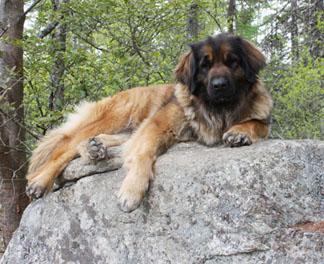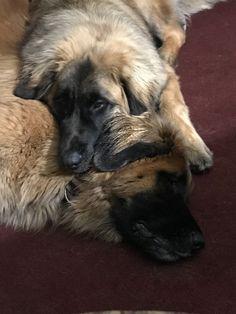The first image is the image on the left, the second image is the image on the right. Examine the images to the left and right. Is the description "An image shows more than one dog lying in a sleeping pose." accurate? Answer yes or no. Yes. The first image is the image on the left, the second image is the image on the right. For the images shown, is this caption "In one of the images there are at least three large dogs laying on the ground next to each other." true? Answer yes or no. No. 